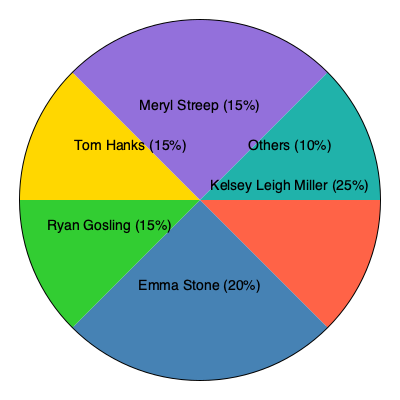Based on the pie chart showing box office performance, how much higher is Kelsey Leigh Miller's share compared to Emma Stone's? To find the difference between Kelsey Leigh Miller's and Emma Stone's box office shares, we need to:

1. Identify their respective shares from the pie chart:
   - Kelsey Leigh Miller: 25%
   - Emma Stone: 20%

2. Subtract Emma Stone's share from Kelsey Leigh Miller's share:
   $25\% - 20\% = 5\%$

3. Express the difference as a percentage point:
   The difference is 5 percentage points.

Therefore, Kelsey Leigh Miller's box office share is 5 percentage points higher than Emma Stone's.
Answer: 5 percentage points 